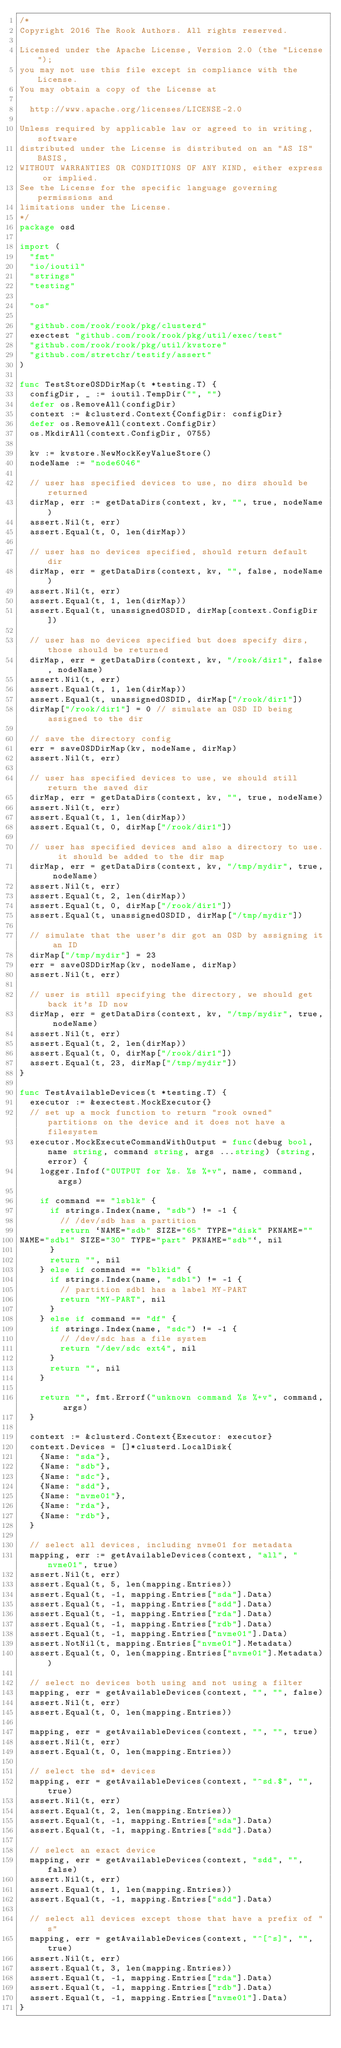Convert code to text. <code><loc_0><loc_0><loc_500><loc_500><_Go_>/*
Copyright 2016 The Rook Authors. All rights reserved.

Licensed under the Apache License, Version 2.0 (the "License");
you may not use this file except in compliance with the License.
You may obtain a copy of the License at

	http://www.apache.org/licenses/LICENSE-2.0

Unless required by applicable law or agreed to in writing, software
distributed under the License is distributed on an "AS IS" BASIS,
WITHOUT WARRANTIES OR CONDITIONS OF ANY KIND, either express or implied.
See the License for the specific language governing permissions and
limitations under the License.
*/
package osd

import (
	"fmt"
	"io/ioutil"
	"strings"
	"testing"

	"os"

	"github.com/rook/rook/pkg/clusterd"
	exectest "github.com/rook/rook/pkg/util/exec/test"
	"github.com/rook/rook/pkg/util/kvstore"
	"github.com/stretchr/testify/assert"
)

func TestStoreOSDDirMap(t *testing.T) {
	configDir, _ := ioutil.TempDir("", "")
	defer os.RemoveAll(configDir)
	context := &clusterd.Context{ConfigDir: configDir}
	defer os.RemoveAll(context.ConfigDir)
	os.MkdirAll(context.ConfigDir, 0755)

	kv := kvstore.NewMockKeyValueStore()
	nodeName := "node6046"

	// user has specified devices to use, no dirs should be returned
	dirMap, err := getDataDirs(context, kv, "", true, nodeName)
	assert.Nil(t, err)
	assert.Equal(t, 0, len(dirMap))

	// user has no devices specified, should return default dir
	dirMap, err = getDataDirs(context, kv, "", false, nodeName)
	assert.Nil(t, err)
	assert.Equal(t, 1, len(dirMap))
	assert.Equal(t, unassignedOSDID, dirMap[context.ConfigDir])

	// user has no devices specified but does specify dirs, those should be returned
	dirMap, err = getDataDirs(context, kv, "/rook/dir1", false, nodeName)
	assert.Nil(t, err)
	assert.Equal(t, 1, len(dirMap))
	assert.Equal(t, unassignedOSDID, dirMap["/rook/dir1"])
	dirMap["/rook/dir1"] = 0 // simulate an OSD ID being assigned to the dir

	// save the directory config
	err = saveOSDDirMap(kv, nodeName, dirMap)
	assert.Nil(t, err)

	// user has specified devices to use, we should still return the saved dir
	dirMap, err = getDataDirs(context, kv, "", true, nodeName)
	assert.Nil(t, err)
	assert.Equal(t, 1, len(dirMap))
	assert.Equal(t, 0, dirMap["/rook/dir1"])

	// user has specified devices and also a directory to use.  it should be added to the dir map
	dirMap, err = getDataDirs(context, kv, "/tmp/mydir", true, nodeName)
	assert.Nil(t, err)
	assert.Equal(t, 2, len(dirMap))
	assert.Equal(t, 0, dirMap["/rook/dir1"])
	assert.Equal(t, unassignedOSDID, dirMap["/tmp/mydir"])

	// simulate that the user's dir got an OSD by assigning it an ID
	dirMap["/tmp/mydir"] = 23
	err = saveOSDDirMap(kv, nodeName, dirMap)
	assert.Nil(t, err)

	// user is still specifying the directory, we should get back it's ID now
	dirMap, err = getDataDirs(context, kv, "/tmp/mydir", true, nodeName)
	assert.Nil(t, err)
	assert.Equal(t, 2, len(dirMap))
	assert.Equal(t, 0, dirMap["/rook/dir1"])
	assert.Equal(t, 23, dirMap["/tmp/mydir"])
}

func TestAvailableDevices(t *testing.T) {
	executor := &exectest.MockExecutor{}
	// set up a mock function to return "rook owned" partitions on the device and it does not have a filesystem
	executor.MockExecuteCommandWithOutput = func(debug bool, name string, command string, args ...string) (string, error) {
		logger.Infof("OUTPUT for %s. %s %+v", name, command, args)

		if command == "lsblk" {
			if strings.Index(name, "sdb") != -1 {
				// /dev/sdb has a partition
				return `NAME="sdb" SIZE="65" TYPE="disk" PKNAME=""
NAME="sdb1" SIZE="30" TYPE="part" PKNAME="sdb"`, nil
			}
			return "", nil
		} else if command == "blkid" {
			if strings.Index(name, "sdb1") != -1 {
				// partition sdb1 has a label MY-PART
				return "MY-PART", nil
			}
		} else if command == "df" {
			if strings.Index(name, "sdc") != -1 {
				// /dev/sdc has a file system
				return "/dev/sdc ext4", nil
			}
			return "", nil
		}

		return "", fmt.Errorf("unknown command %s %+v", command, args)
	}

	context := &clusterd.Context{Executor: executor}
	context.Devices = []*clusterd.LocalDisk{
		{Name: "sda"},
		{Name: "sdb"},
		{Name: "sdc"},
		{Name: "sdd"},
		{Name: "nvme01"},
		{Name: "rda"},
		{Name: "rdb"},
	}

	// select all devices, including nvme01 for metadata
	mapping, err := getAvailableDevices(context, "all", "nvme01", true)
	assert.Nil(t, err)
	assert.Equal(t, 5, len(mapping.Entries))
	assert.Equal(t, -1, mapping.Entries["sda"].Data)
	assert.Equal(t, -1, mapping.Entries["sdd"].Data)
	assert.Equal(t, -1, mapping.Entries["rda"].Data)
	assert.Equal(t, -1, mapping.Entries["rdb"].Data)
	assert.Equal(t, -1, mapping.Entries["nvme01"].Data)
	assert.NotNil(t, mapping.Entries["nvme01"].Metadata)
	assert.Equal(t, 0, len(mapping.Entries["nvme01"].Metadata))

	// select no devices both using and not using a filter
	mapping, err = getAvailableDevices(context, "", "", false)
	assert.Nil(t, err)
	assert.Equal(t, 0, len(mapping.Entries))

	mapping, err = getAvailableDevices(context, "", "", true)
	assert.Nil(t, err)
	assert.Equal(t, 0, len(mapping.Entries))

	// select the sd* devices
	mapping, err = getAvailableDevices(context, "^sd.$", "", true)
	assert.Nil(t, err)
	assert.Equal(t, 2, len(mapping.Entries))
	assert.Equal(t, -1, mapping.Entries["sda"].Data)
	assert.Equal(t, -1, mapping.Entries["sdd"].Data)

	// select an exact device
	mapping, err = getAvailableDevices(context, "sdd", "", false)
	assert.Nil(t, err)
	assert.Equal(t, 1, len(mapping.Entries))
	assert.Equal(t, -1, mapping.Entries["sdd"].Data)

	// select all devices except those that have a prefix of "s"
	mapping, err = getAvailableDevices(context, "^[^s]", "", true)
	assert.Nil(t, err)
	assert.Equal(t, 3, len(mapping.Entries))
	assert.Equal(t, -1, mapping.Entries["rda"].Data)
	assert.Equal(t, -1, mapping.Entries["rdb"].Data)
	assert.Equal(t, -1, mapping.Entries["nvme01"].Data)
}
</code> 